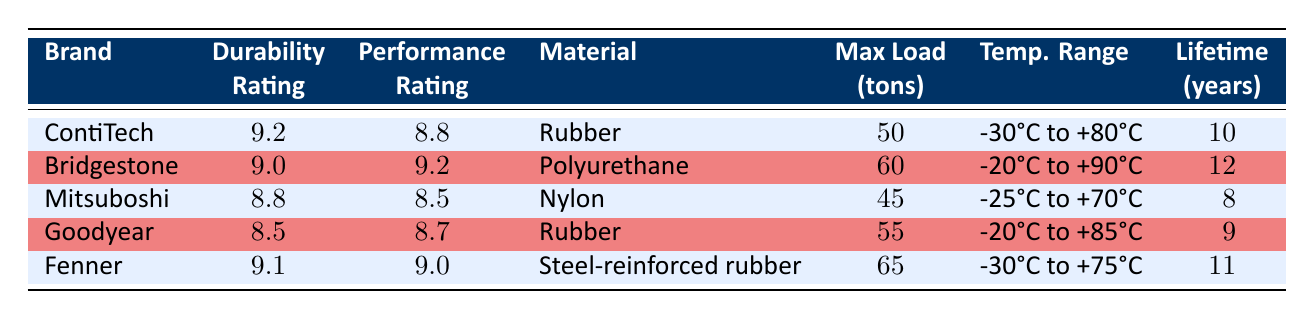What is the durability rating of Bridgestone? The table lists Bridgestone's durability rating directly under the "Durability" column, which shows a rating of 9.0.
Answer: 9.0 Which brand has the highest max load capacity? By comparing the "Max Load" column, Fenner has a max load capacity of 65 tons, which is the highest among all listed brands.
Answer: Fenner What is the average lifetime of conveyor belts in the table? To calculate the average lifetime, sum the values (10 + 12 + 8 + 9 + 11 = 50) and divide by 5 (the number of brands), giving an average of 50 / 5 = 10.
Answer: 10 years Is the material of Goodyear conveyor belts rubber? According to the "Material" column, Goodyear is indeed listed as having rubber as its material.
Answer: Yes Which brand has both the highest durability rating and temperature range? By analyzing both the "Durability" and "Temperature Range" columns, ContiTech has the highest durability rating of 9.2, but it doesn't have the highest temperature range. Bridgestone has a higher temperature range of -20°C to +90°C. However, Fenner with a durability rating of 9.1 has a temperature range of -30°C to +75°C. Therefore Bridgestone and ContiTech do not hold both highest values.
Answer: None What is the difference in performance rating between Fenner and Mitsuboshi? The performance rating for Fenner is 9.0 and for Mitsuboshi is 8.5. The difference is calculated as 9.0 - 8.5 = 0.5.
Answer: 0.5 Which brands have an average lifetime of 10 years or more? Checking the "Lifetime" column, the brands with an average lifetime of 10 years or more are Bridgestone (12), Fenner (11), and ContiTech (10).
Answer: Bridgestone, Fenner, ContiTech What temperature range can the Bridgestone conveyor belts handle? The "Temperature Range" column shows that Bridgestone can handle temperatures from -20°C to +90°C.
Answer: -20°C to +90°C Does any conveyor belt material have a higher durability rating than rubber? By examining the "Material" and "Durability" columns, Bridgestone (Polyurethane, 9.0) and Fenner (Steel-reinforced rubber, 9.1) have higher durability ratings than those listed as rubber (Goodyear at 8.5 and ContiTech at 9.2).
Answer: Yes 